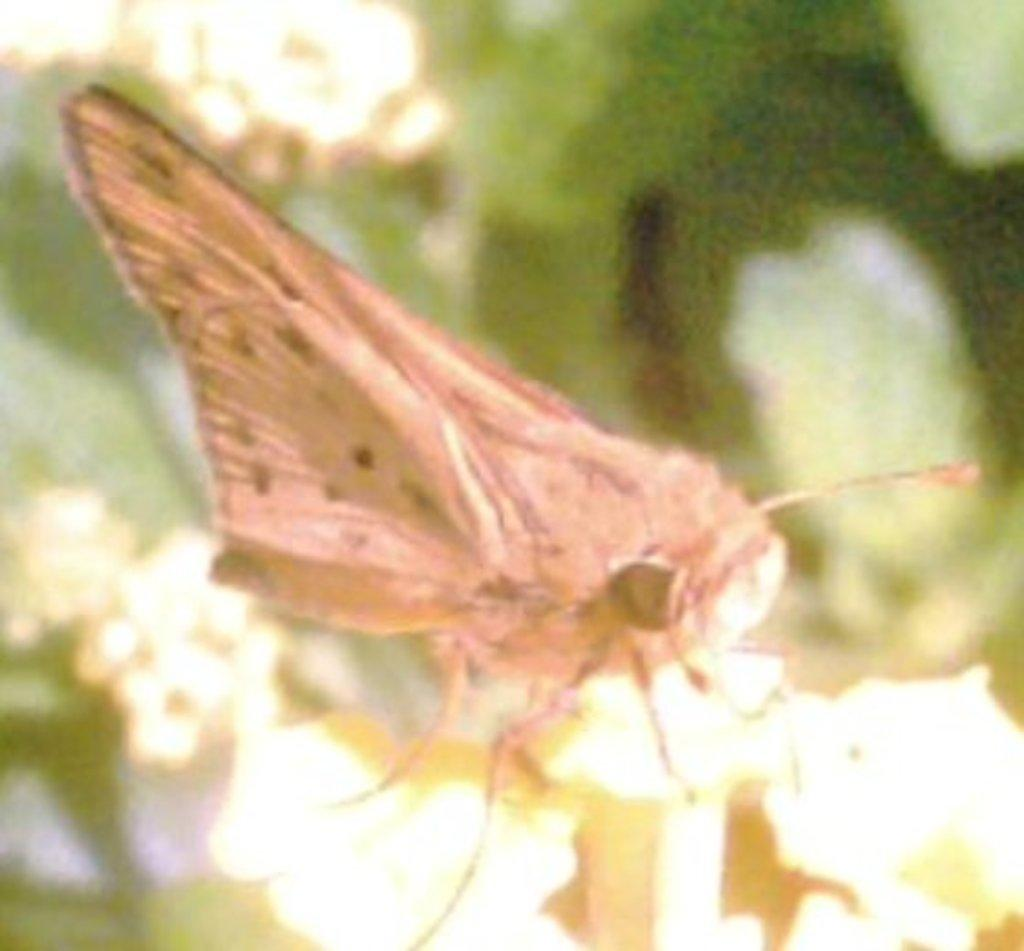What is the main subject in the image? There is a butterfly in the image. Where is the butterfly located? The butterfly is on a wooden pole. Can you describe the background of the image? The background of the image is blurred. What type of toys can be seen being used in the protest in the image? There is no protest or toys present in the image; it features a butterfly on a wooden pole with a blurred background. 